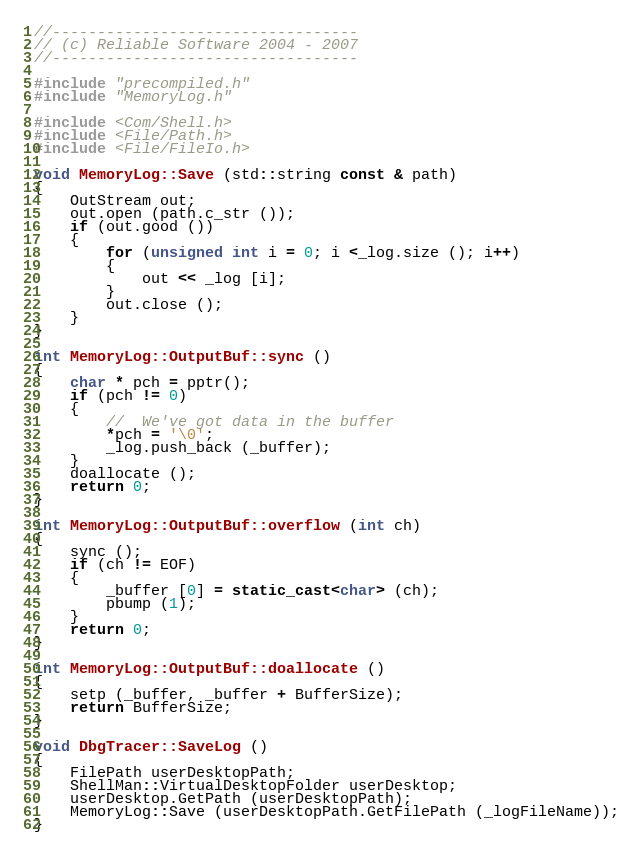<code> <loc_0><loc_0><loc_500><loc_500><_C++_>//----------------------------------
// (c) Reliable Software 2004 - 2007
//----------------------------------

#include "precompiled.h"
#include "MemoryLog.h"

#include <Com/Shell.h>
#include <File/Path.h>
#include <File/FileIo.h>

void MemoryLog::Save (std::string const & path)
{
	OutStream out;
	out.open (path.c_str ());
	if (out.good ())
	{
		for (unsigned int i = 0; i <_log.size (); i++)
		{
			out << _log [i];
		}
		out.close ();
	}
}

int MemoryLog::OutputBuf::sync ()
{
	char * pch = pptr();
	if (pch != 0)
	{
		//	We've got data in the buffer
		*pch = '\0';
		_log.push_back (_buffer);
	}
	doallocate ();
	return 0;
}

int MemoryLog::OutputBuf::overflow (int ch)
{
	sync ();
	if (ch != EOF)
	{
		_buffer [0] = static_cast<char> (ch);
		pbump (1);
	}
	return 0;
}

int MemoryLog::OutputBuf::doallocate ()
{
	setp (_buffer, _buffer + BufferSize);
	return BufferSize;
}

void DbgTracer::SaveLog ()
{
	FilePath userDesktopPath;
	ShellMan::VirtualDesktopFolder userDesktop;
	userDesktop.GetPath (userDesktopPath);
	MemoryLog::Save (userDesktopPath.GetFilePath (_logFileName));
}
</code> 